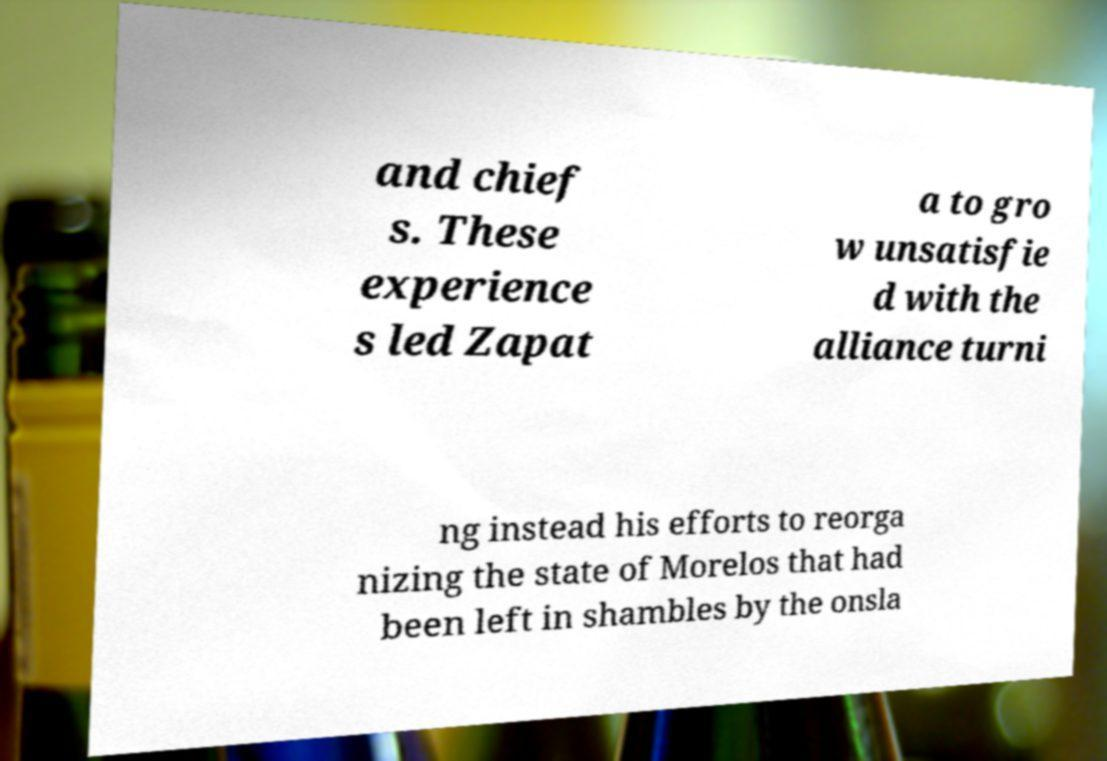Please identify and transcribe the text found in this image. and chief s. These experience s led Zapat a to gro w unsatisfie d with the alliance turni ng instead his efforts to reorga nizing the state of Morelos that had been left in shambles by the onsla 